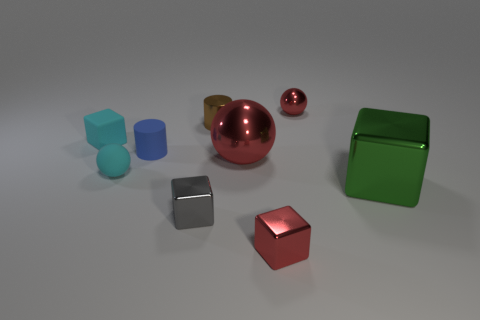Subtract all blue cubes. How many red balls are left? 2 Subtract 1 balls. How many balls are left? 2 Subtract all gray cubes. How many cubes are left? 3 Subtract all tiny cyan matte cubes. How many cubes are left? 3 Subtract all brown blocks. Subtract all brown balls. How many blocks are left? 4 Add 1 small cyan objects. How many objects exist? 10 Subtract all spheres. How many objects are left? 6 Add 2 small cyan matte cubes. How many small cyan matte cubes exist? 3 Subtract 1 cyan spheres. How many objects are left? 8 Subtract all cylinders. Subtract all large red shiny things. How many objects are left? 6 